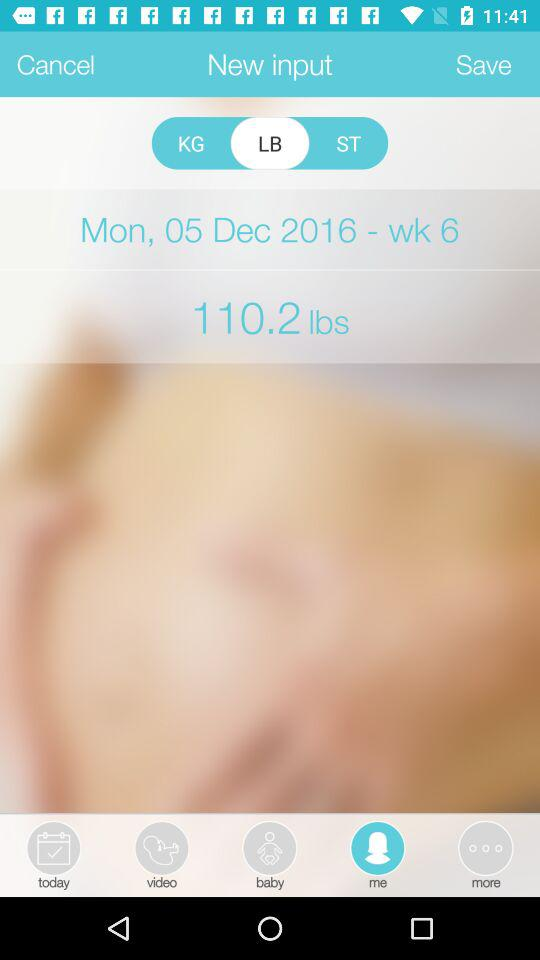Which option is selected? The selected options are "LB" and "me". 